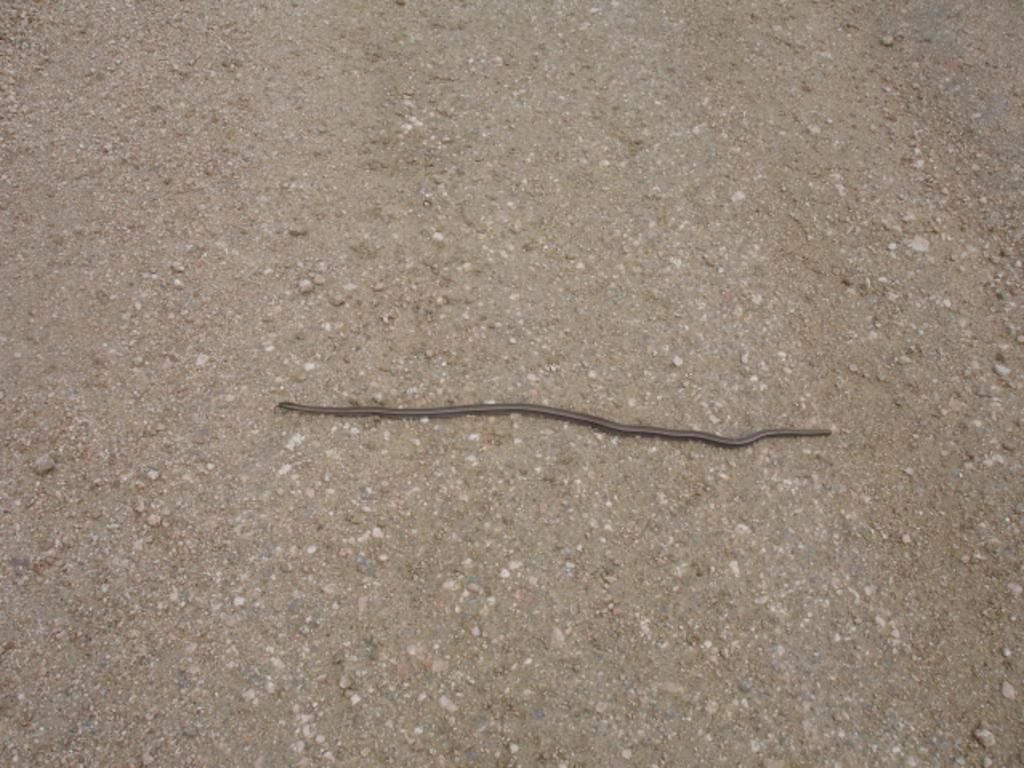What type of animal can be seen in the image? There is a black animal in the image. Where is the animal located in the image? The animal is on the ground. What is the animal's tendency to make decisions in the image? There is no indication of the animal's decision-making process in the image, as animals do not make decisions in the same way humans do. 